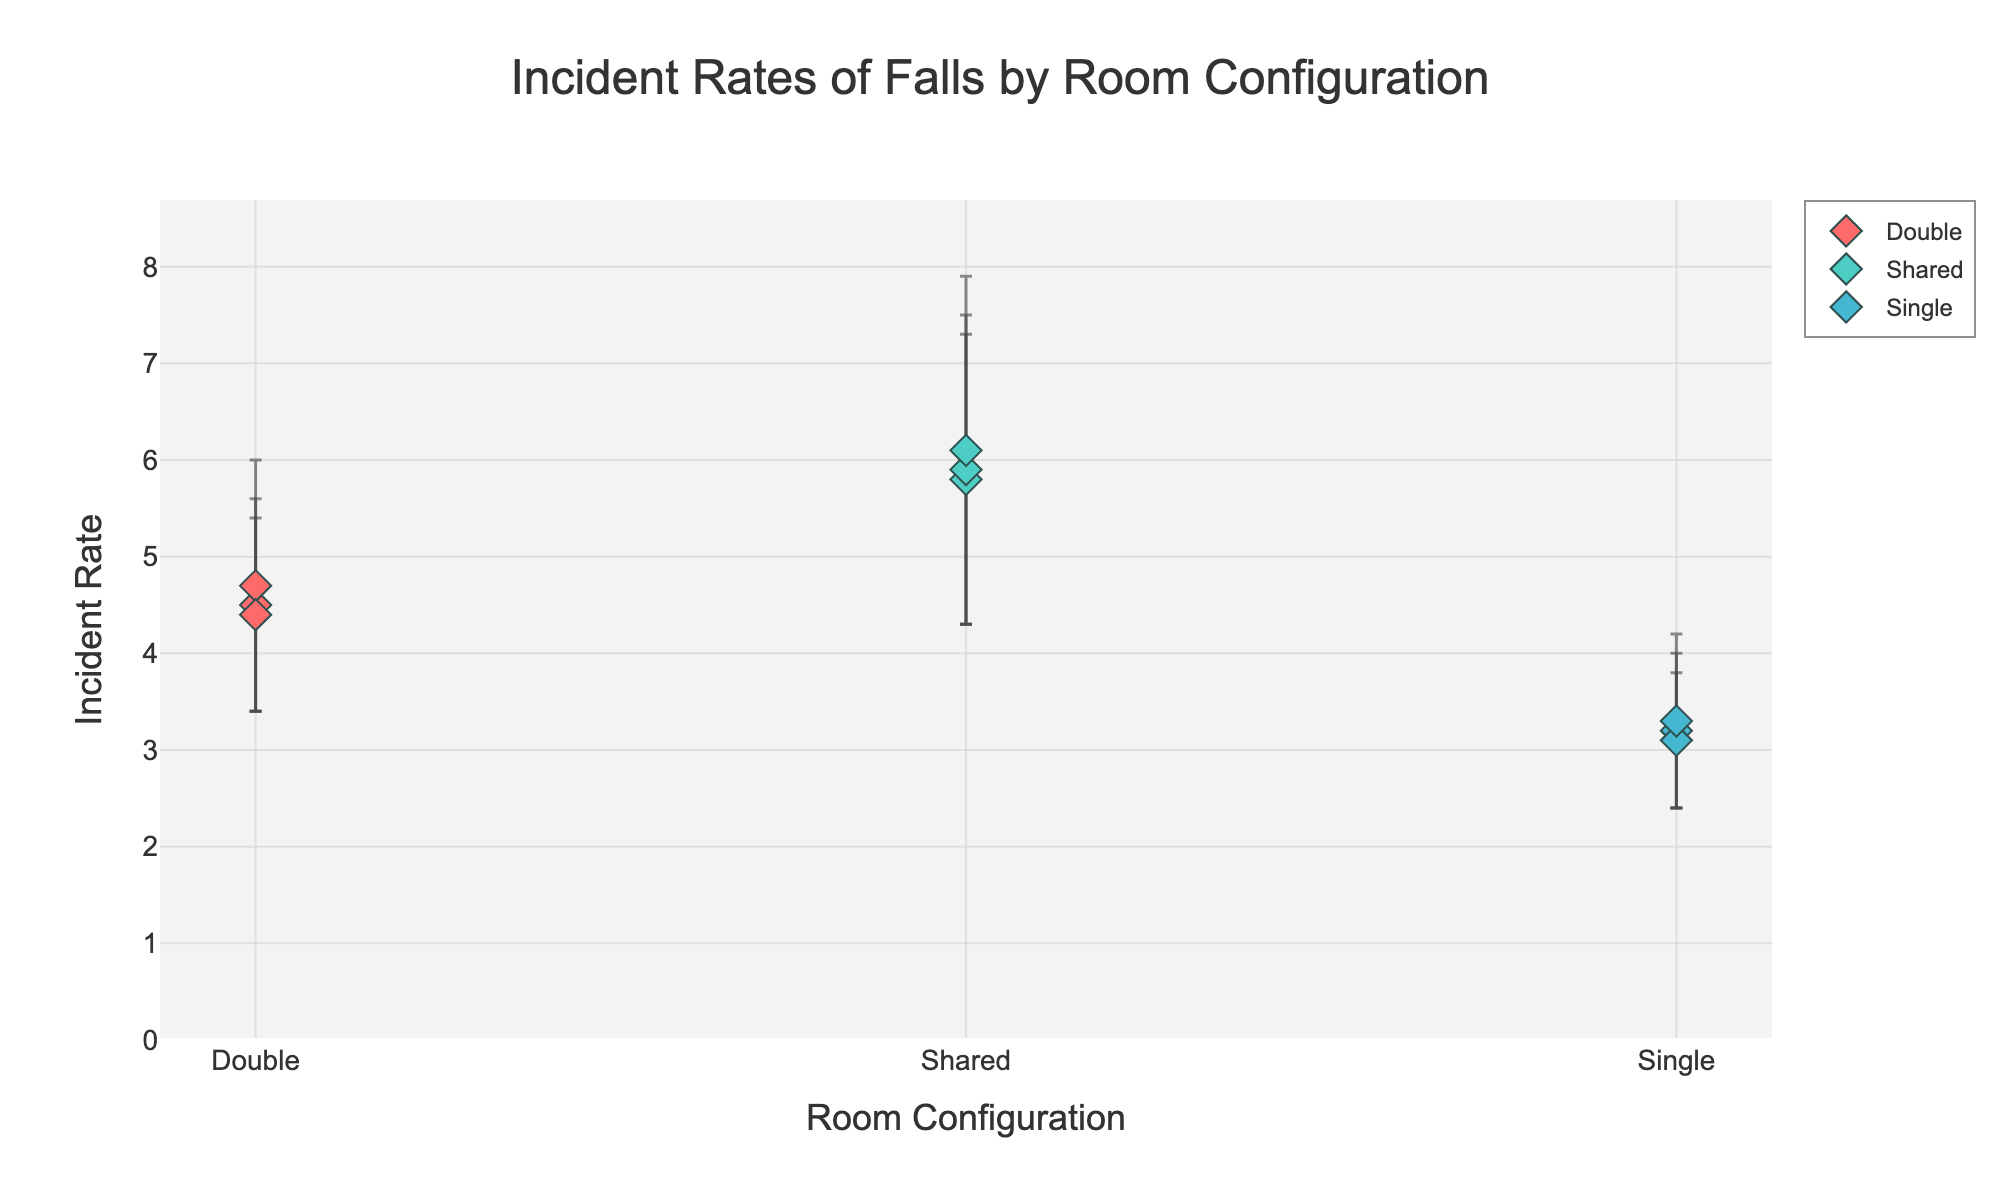What is the title of the figure? The title of the figure is displayed prominently at the top of the chart. It informs the viewer about what the graph is depicting.
Answer: Incident Rates of Falls by Room Configuration How many different room configurations are presented in the figure? By observing the x-axis labels, we can count the different room configurations.
Answer: 3 Which room configuration has the highest incident rate of falls? By looking at the y-axis values, the highest data points belong to the "Shared" room configuration.
Answer: Shared What is the range of incident rates for the "Single" room configuration? The incident rates for the "Single" room configuration are between the lowest and highest points marked for this category.
Answer: 3.1 to 3.3 Which room configuration shows the largest variation in incident rates? To determine this, we need to consider both the range of incident rates and the size of the standard deviations (error bars). The "Shared" configuration has the largest error bars combined with the wider spread of data points.
Answer: Shared What is the average incident rate for the "Double" room configuration? Add up the incident rates for the "Double" room configuration and divide by the number of data points: (4.5 + 4.7 + 4.4)/3.
Answer: 4.53 What is the average standard deviation for the "Shared" room configuration? Add up the standard deviations for the "Shared" room configuration and divide by the number of data points: (1.5 + 1.6 + 1.8)/3.
Answer: 1.63 How does the average incident rate for "Single" rooms compare to "Double" rooms? Calculate the average incident rate for each configuration (Single: (3.2 + 3.1 + 3.3)/3 and Double: (4.5 + 4.7 + 4.4)/3) and compare them.
Answer: "Single" has a lower average incident rate Which room configuration shows the smallest standard deviation? Evaluate the standard deviations presented in the error bars for all configurations. The "Single" room configuration consistently shows the smallest error bars.
Answer: Single 